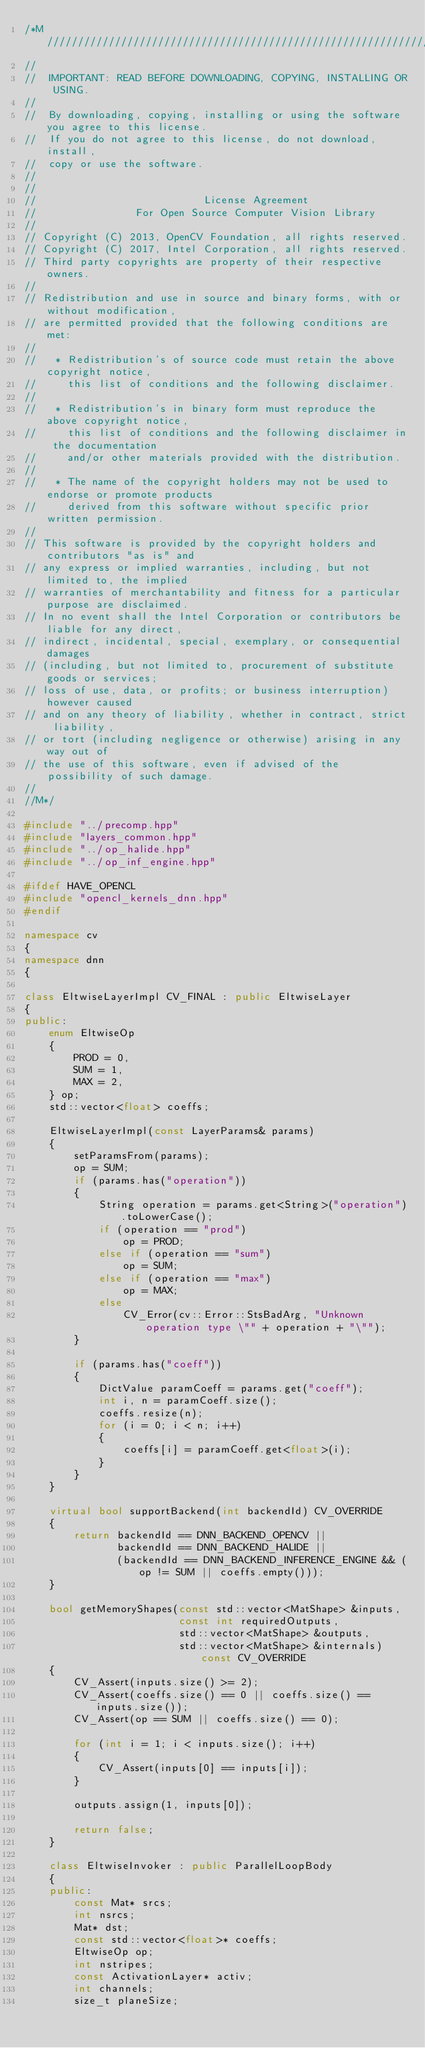Convert code to text. <code><loc_0><loc_0><loc_500><loc_500><_C++_>/*M///////////////////////////////////////////////////////////////////////////////////////
//
//  IMPORTANT: READ BEFORE DOWNLOADING, COPYING, INSTALLING OR USING.
//
//  By downloading, copying, installing or using the software you agree to this license.
//  If you do not agree to this license, do not download, install,
//  copy or use the software.
//
//
//                           License Agreement
//                For Open Source Computer Vision Library
//
// Copyright (C) 2013, OpenCV Foundation, all rights reserved.
// Copyright (C) 2017, Intel Corporation, all rights reserved.
// Third party copyrights are property of their respective owners.
//
// Redistribution and use in source and binary forms, with or without modification,
// are permitted provided that the following conditions are met:
//
//   * Redistribution's of source code must retain the above copyright notice,
//     this list of conditions and the following disclaimer.
//
//   * Redistribution's in binary form must reproduce the above copyright notice,
//     this list of conditions and the following disclaimer in the documentation
//     and/or other materials provided with the distribution.
//
//   * The name of the copyright holders may not be used to endorse or promote products
//     derived from this software without specific prior written permission.
//
// This software is provided by the copyright holders and contributors "as is" and
// any express or implied warranties, including, but not limited to, the implied
// warranties of merchantability and fitness for a particular purpose are disclaimed.
// In no event shall the Intel Corporation or contributors be liable for any direct,
// indirect, incidental, special, exemplary, or consequential damages
// (including, but not limited to, procurement of substitute goods or services;
// loss of use, data, or profits; or business interruption) however caused
// and on any theory of liability, whether in contract, strict liability,
// or tort (including negligence or otherwise) arising in any way out of
// the use of this software, even if advised of the possibility of such damage.
//
//M*/

#include "../precomp.hpp"
#include "layers_common.hpp"
#include "../op_halide.hpp"
#include "../op_inf_engine.hpp"

#ifdef HAVE_OPENCL
#include "opencl_kernels_dnn.hpp"
#endif

namespace cv
{
namespace dnn
{

class EltwiseLayerImpl CV_FINAL : public EltwiseLayer
{
public:
    enum EltwiseOp
    {
        PROD = 0,
        SUM = 1,
        MAX = 2,
    } op;
    std::vector<float> coeffs;

    EltwiseLayerImpl(const LayerParams& params)
    {
        setParamsFrom(params);
        op = SUM;
        if (params.has("operation"))
        {
            String operation = params.get<String>("operation").toLowerCase();
            if (operation == "prod")
                op = PROD;
            else if (operation == "sum")
                op = SUM;
            else if (operation == "max")
                op = MAX;
            else
                CV_Error(cv::Error::StsBadArg, "Unknown operation type \"" + operation + "\"");
        }

        if (params.has("coeff"))
        {
            DictValue paramCoeff = params.get("coeff");
            int i, n = paramCoeff.size();
            coeffs.resize(n);
            for (i = 0; i < n; i++)
            {
                coeffs[i] = paramCoeff.get<float>(i);
            }
        }
    }

    virtual bool supportBackend(int backendId) CV_OVERRIDE
    {
        return backendId == DNN_BACKEND_OPENCV ||
               backendId == DNN_BACKEND_HALIDE ||
               (backendId == DNN_BACKEND_INFERENCE_ENGINE && (op != SUM || coeffs.empty()));
    }

    bool getMemoryShapes(const std::vector<MatShape> &inputs,
                         const int requiredOutputs,
                         std::vector<MatShape> &outputs,
                         std::vector<MatShape> &internals) const CV_OVERRIDE
    {
        CV_Assert(inputs.size() >= 2);
        CV_Assert(coeffs.size() == 0 || coeffs.size() == inputs.size());
        CV_Assert(op == SUM || coeffs.size() == 0);

        for (int i = 1; i < inputs.size(); i++)
        {
            CV_Assert(inputs[0] == inputs[i]);
        }

        outputs.assign(1, inputs[0]);

        return false;
    }

    class EltwiseInvoker : public ParallelLoopBody
    {
    public:
        const Mat* srcs;
        int nsrcs;
        Mat* dst;
        const std::vector<float>* coeffs;
        EltwiseOp op;
        int nstripes;
        const ActivationLayer* activ;
        int channels;
        size_t planeSize;
</code> 